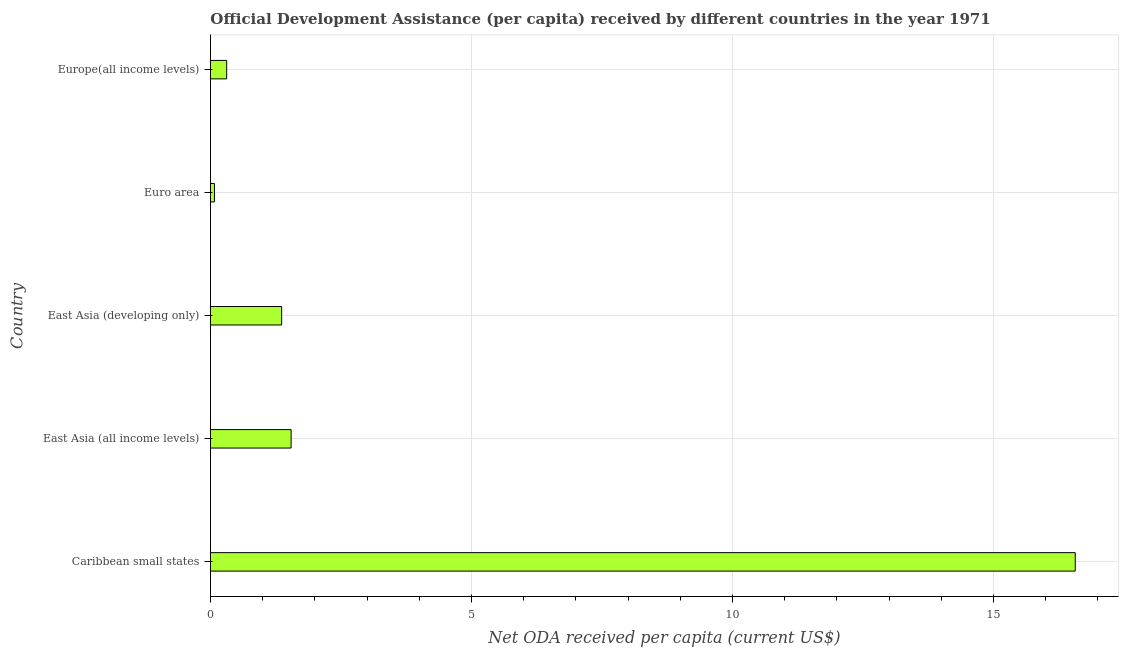Does the graph contain grids?
Your answer should be very brief. Yes. What is the title of the graph?
Keep it short and to the point. Official Development Assistance (per capita) received by different countries in the year 1971. What is the label or title of the X-axis?
Your answer should be compact. Net ODA received per capita (current US$). What is the net oda received per capita in East Asia (all income levels)?
Keep it short and to the point. 1.54. Across all countries, what is the maximum net oda received per capita?
Ensure brevity in your answer.  16.57. Across all countries, what is the minimum net oda received per capita?
Make the answer very short. 0.08. In which country was the net oda received per capita maximum?
Offer a terse response. Caribbean small states. What is the sum of the net oda received per capita?
Make the answer very short. 19.86. What is the difference between the net oda received per capita in Caribbean small states and East Asia (all income levels)?
Keep it short and to the point. 15.02. What is the average net oda received per capita per country?
Your response must be concise. 3.97. What is the median net oda received per capita?
Make the answer very short. 1.36. What is the ratio of the net oda received per capita in East Asia (developing only) to that in Euro area?
Provide a short and direct response. 17.89. Is the net oda received per capita in Caribbean small states less than that in Euro area?
Provide a short and direct response. No. Is the difference between the net oda received per capita in Caribbean small states and Euro area greater than the difference between any two countries?
Keep it short and to the point. Yes. What is the difference between the highest and the second highest net oda received per capita?
Offer a terse response. 15.02. Is the sum of the net oda received per capita in Caribbean small states and Europe(all income levels) greater than the maximum net oda received per capita across all countries?
Give a very brief answer. Yes. What is the difference between the highest and the lowest net oda received per capita?
Your answer should be very brief. 16.49. In how many countries, is the net oda received per capita greater than the average net oda received per capita taken over all countries?
Offer a terse response. 1. How many bars are there?
Keep it short and to the point. 5. How many countries are there in the graph?
Your answer should be compact. 5. Are the values on the major ticks of X-axis written in scientific E-notation?
Offer a terse response. No. What is the Net ODA received per capita (current US$) of Caribbean small states?
Offer a very short reply. 16.57. What is the Net ODA received per capita (current US$) in East Asia (all income levels)?
Keep it short and to the point. 1.54. What is the Net ODA received per capita (current US$) of East Asia (developing only)?
Offer a terse response. 1.36. What is the Net ODA received per capita (current US$) of Euro area?
Provide a short and direct response. 0.08. What is the Net ODA received per capita (current US$) in Europe(all income levels)?
Your answer should be compact. 0.31. What is the difference between the Net ODA received per capita (current US$) in Caribbean small states and East Asia (all income levels)?
Ensure brevity in your answer.  15.02. What is the difference between the Net ODA received per capita (current US$) in Caribbean small states and East Asia (developing only)?
Provide a short and direct response. 15.2. What is the difference between the Net ODA received per capita (current US$) in Caribbean small states and Euro area?
Provide a short and direct response. 16.49. What is the difference between the Net ODA received per capita (current US$) in Caribbean small states and Europe(all income levels)?
Provide a succinct answer. 16.26. What is the difference between the Net ODA received per capita (current US$) in East Asia (all income levels) and East Asia (developing only)?
Make the answer very short. 0.18. What is the difference between the Net ODA received per capita (current US$) in East Asia (all income levels) and Euro area?
Keep it short and to the point. 1.47. What is the difference between the Net ODA received per capita (current US$) in East Asia (all income levels) and Europe(all income levels)?
Your response must be concise. 1.23. What is the difference between the Net ODA received per capita (current US$) in East Asia (developing only) and Euro area?
Give a very brief answer. 1.29. What is the difference between the Net ODA received per capita (current US$) in East Asia (developing only) and Europe(all income levels)?
Make the answer very short. 1.05. What is the difference between the Net ODA received per capita (current US$) in Euro area and Europe(all income levels)?
Your answer should be compact. -0.23. What is the ratio of the Net ODA received per capita (current US$) in Caribbean small states to that in East Asia (all income levels)?
Your answer should be very brief. 10.72. What is the ratio of the Net ODA received per capita (current US$) in Caribbean small states to that in East Asia (developing only)?
Provide a short and direct response. 12.15. What is the ratio of the Net ODA received per capita (current US$) in Caribbean small states to that in Euro area?
Provide a succinct answer. 217.43. What is the ratio of the Net ODA received per capita (current US$) in Caribbean small states to that in Europe(all income levels)?
Your response must be concise. 53.33. What is the ratio of the Net ODA received per capita (current US$) in East Asia (all income levels) to that in East Asia (developing only)?
Offer a terse response. 1.13. What is the ratio of the Net ODA received per capita (current US$) in East Asia (all income levels) to that in Euro area?
Give a very brief answer. 20.27. What is the ratio of the Net ODA received per capita (current US$) in East Asia (all income levels) to that in Europe(all income levels)?
Make the answer very short. 4.97. What is the ratio of the Net ODA received per capita (current US$) in East Asia (developing only) to that in Euro area?
Ensure brevity in your answer.  17.89. What is the ratio of the Net ODA received per capita (current US$) in East Asia (developing only) to that in Europe(all income levels)?
Provide a succinct answer. 4.39. What is the ratio of the Net ODA received per capita (current US$) in Euro area to that in Europe(all income levels)?
Make the answer very short. 0.24. 